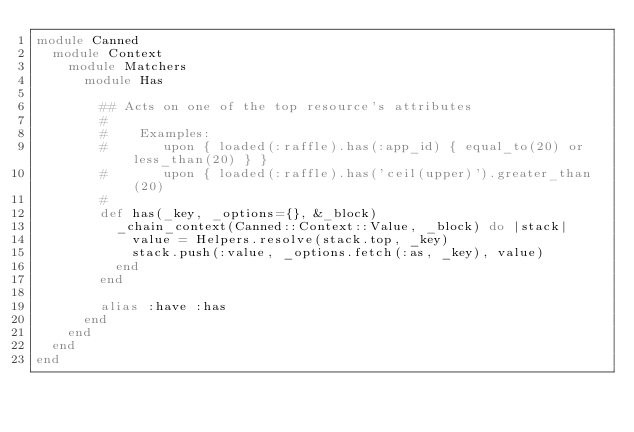<code> <loc_0><loc_0><loc_500><loc_500><_Ruby_>module Canned
  module Context
    module Matchers
      module Has

        ## Acts on one of the top resource's attributes
        #
        #    Examples:
        #       upon { loaded(:raffle).has(:app_id) { equal_to(20) or less_than(20) } }
        #       upon { loaded(:raffle).has('ceil(upper)').greater_than(20)
        #
        def has(_key, _options={}, &_block)
          _chain_context(Canned::Context::Value, _block) do |stack|
            value = Helpers.resolve(stack.top, _key)
            stack.push(:value, _options.fetch(:as, _key), value)
          end
        end

        alias :have :has
      end
    end
  end
end</code> 